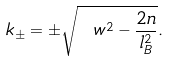<formula> <loc_0><loc_0><loc_500><loc_500>k _ { \pm } = \pm \sqrt { \ w ^ { 2 } - \frac { 2 n } { l _ { B } ^ { 2 } } } .</formula> 